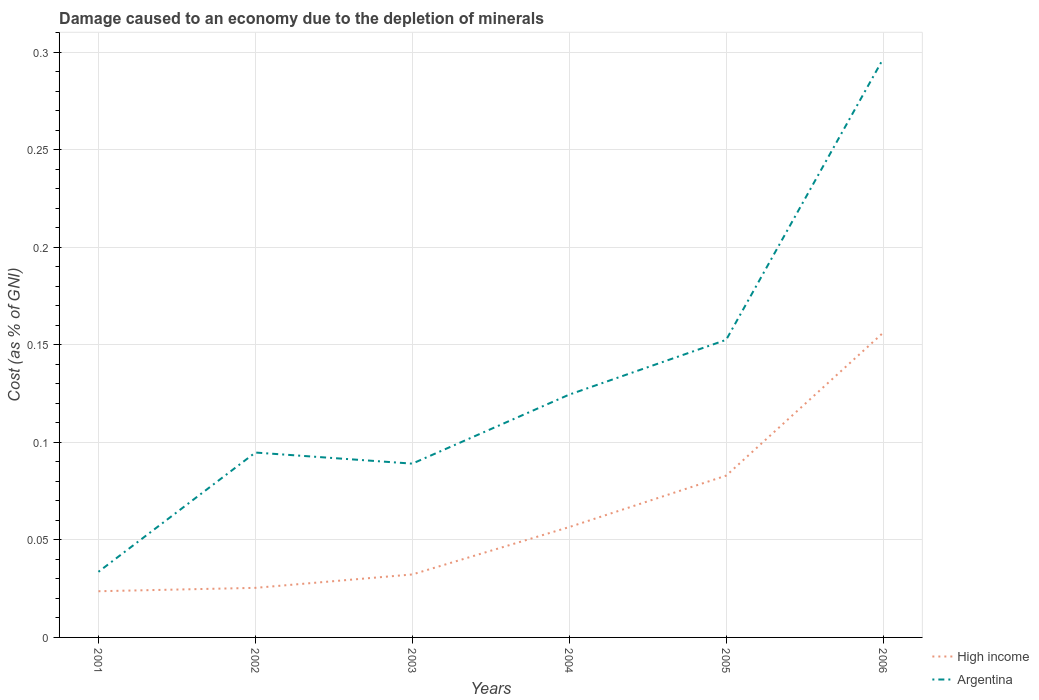How many different coloured lines are there?
Your answer should be very brief. 2. Across all years, what is the maximum cost of damage caused due to the depletion of minerals in Argentina?
Make the answer very short. 0.03. What is the total cost of damage caused due to the depletion of minerals in Argentina in the graph?
Your answer should be compact. -0.17. What is the difference between the highest and the second highest cost of damage caused due to the depletion of minerals in High income?
Your answer should be very brief. 0.13. What is the difference between the highest and the lowest cost of damage caused due to the depletion of minerals in Argentina?
Give a very brief answer. 2. Is the cost of damage caused due to the depletion of minerals in Argentina strictly greater than the cost of damage caused due to the depletion of minerals in High income over the years?
Make the answer very short. No. How many lines are there?
Keep it short and to the point. 2. What is the difference between two consecutive major ticks on the Y-axis?
Offer a terse response. 0.05. Does the graph contain grids?
Ensure brevity in your answer.  Yes. What is the title of the graph?
Your answer should be very brief. Damage caused to an economy due to the depletion of minerals. Does "Luxembourg" appear as one of the legend labels in the graph?
Offer a very short reply. No. What is the label or title of the Y-axis?
Your response must be concise. Cost (as % of GNI). What is the Cost (as % of GNI) of High income in 2001?
Make the answer very short. 0.02. What is the Cost (as % of GNI) in Argentina in 2001?
Offer a very short reply. 0.03. What is the Cost (as % of GNI) in High income in 2002?
Provide a short and direct response. 0.03. What is the Cost (as % of GNI) in Argentina in 2002?
Provide a short and direct response. 0.09. What is the Cost (as % of GNI) of High income in 2003?
Provide a succinct answer. 0.03. What is the Cost (as % of GNI) of Argentina in 2003?
Give a very brief answer. 0.09. What is the Cost (as % of GNI) of High income in 2004?
Your response must be concise. 0.06. What is the Cost (as % of GNI) in Argentina in 2004?
Keep it short and to the point. 0.12. What is the Cost (as % of GNI) in High income in 2005?
Give a very brief answer. 0.08. What is the Cost (as % of GNI) in Argentina in 2005?
Keep it short and to the point. 0.15. What is the Cost (as % of GNI) in High income in 2006?
Your response must be concise. 0.16. What is the Cost (as % of GNI) of Argentina in 2006?
Ensure brevity in your answer.  0.3. Across all years, what is the maximum Cost (as % of GNI) in High income?
Provide a succinct answer. 0.16. Across all years, what is the maximum Cost (as % of GNI) in Argentina?
Give a very brief answer. 0.3. Across all years, what is the minimum Cost (as % of GNI) of High income?
Make the answer very short. 0.02. Across all years, what is the minimum Cost (as % of GNI) in Argentina?
Your response must be concise. 0.03. What is the total Cost (as % of GNI) in High income in the graph?
Provide a succinct answer. 0.38. What is the total Cost (as % of GNI) of Argentina in the graph?
Your response must be concise. 0.79. What is the difference between the Cost (as % of GNI) of High income in 2001 and that in 2002?
Your answer should be very brief. -0. What is the difference between the Cost (as % of GNI) in Argentina in 2001 and that in 2002?
Your answer should be very brief. -0.06. What is the difference between the Cost (as % of GNI) of High income in 2001 and that in 2003?
Keep it short and to the point. -0.01. What is the difference between the Cost (as % of GNI) in Argentina in 2001 and that in 2003?
Your answer should be compact. -0.06. What is the difference between the Cost (as % of GNI) of High income in 2001 and that in 2004?
Offer a terse response. -0.03. What is the difference between the Cost (as % of GNI) in Argentina in 2001 and that in 2004?
Your answer should be very brief. -0.09. What is the difference between the Cost (as % of GNI) in High income in 2001 and that in 2005?
Offer a very short reply. -0.06. What is the difference between the Cost (as % of GNI) of Argentina in 2001 and that in 2005?
Keep it short and to the point. -0.12. What is the difference between the Cost (as % of GNI) in High income in 2001 and that in 2006?
Your answer should be very brief. -0.13. What is the difference between the Cost (as % of GNI) of Argentina in 2001 and that in 2006?
Provide a short and direct response. -0.26. What is the difference between the Cost (as % of GNI) in High income in 2002 and that in 2003?
Give a very brief answer. -0.01. What is the difference between the Cost (as % of GNI) of Argentina in 2002 and that in 2003?
Offer a terse response. 0.01. What is the difference between the Cost (as % of GNI) of High income in 2002 and that in 2004?
Offer a terse response. -0.03. What is the difference between the Cost (as % of GNI) of Argentina in 2002 and that in 2004?
Offer a very short reply. -0.03. What is the difference between the Cost (as % of GNI) in High income in 2002 and that in 2005?
Offer a terse response. -0.06. What is the difference between the Cost (as % of GNI) of Argentina in 2002 and that in 2005?
Offer a terse response. -0.06. What is the difference between the Cost (as % of GNI) in High income in 2002 and that in 2006?
Offer a terse response. -0.13. What is the difference between the Cost (as % of GNI) of Argentina in 2002 and that in 2006?
Provide a short and direct response. -0.2. What is the difference between the Cost (as % of GNI) in High income in 2003 and that in 2004?
Give a very brief answer. -0.02. What is the difference between the Cost (as % of GNI) in Argentina in 2003 and that in 2004?
Offer a very short reply. -0.04. What is the difference between the Cost (as % of GNI) in High income in 2003 and that in 2005?
Make the answer very short. -0.05. What is the difference between the Cost (as % of GNI) in Argentina in 2003 and that in 2005?
Keep it short and to the point. -0.06. What is the difference between the Cost (as % of GNI) in High income in 2003 and that in 2006?
Give a very brief answer. -0.12. What is the difference between the Cost (as % of GNI) of Argentina in 2003 and that in 2006?
Your answer should be very brief. -0.21. What is the difference between the Cost (as % of GNI) in High income in 2004 and that in 2005?
Make the answer very short. -0.03. What is the difference between the Cost (as % of GNI) of Argentina in 2004 and that in 2005?
Ensure brevity in your answer.  -0.03. What is the difference between the Cost (as % of GNI) in High income in 2004 and that in 2006?
Your response must be concise. -0.1. What is the difference between the Cost (as % of GNI) in Argentina in 2004 and that in 2006?
Your response must be concise. -0.17. What is the difference between the Cost (as % of GNI) of High income in 2005 and that in 2006?
Provide a short and direct response. -0.07. What is the difference between the Cost (as % of GNI) of Argentina in 2005 and that in 2006?
Ensure brevity in your answer.  -0.14. What is the difference between the Cost (as % of GNI) in High income in 2001 and the Cost (as % of GNI) in Argentina in 2002?
Keep it short and to the point. -0.07. What is the difference between the Cost (as % of GNI) in High income in 2001 and the Cost (as % of GNI) in Argentina in 2003?
Your response must be concise. -0.07. What is the difference between the Cost (as % of GNI) of High income in 2001 and the Cost (as % of GNI) of Argentina in 2004?
Your response must be concise. -0.1. What is the difference between the Cost (as % of GNI) in High income in 2001 and the Cost (as % of GNI) in Argentina in 2005?
Your answer should be very brief. -0.13. What is the difference between the Cost (as % of GNI) of High income in 2001 and the Cost (as % of GNI) of Argentina in 2006?
Offer a very short reply. -0.27. What is the difference between the Cost (as % of GNI) in High income in 2002 and the Cost (as % of GNI) in Argentina in 2003?
Offer a very short reply. -0.06. What is the difference between the Cost (as % of GNI) of High income in 2002 and the Cost (as % of GNI) of Argentina in 2004?
Provide a short and direct response. -0.1. What is the difference between the Cost (as % of GNI) of High income in 2002 and the Cost (as % of GNI) of Argentina in 2005?
Offer a very short reply. -0.13. What is the difference between the Cost (as % of GNI) of High income in 2002 and the Cost (as % of GNI) of Argentina in 2006?
Your response must be concise. -0.27. What is the difference between the Cost (as % of GNI) in High income in 2003 and the Cost (as % of GNI) in Argentina in 2004?
Provide a short and direct response. -0.09. What is the difference between the Cost (as % of GNI) of High income in 2003 and the Cost (as % of GNI) of Argentina in 2005?
Your answer should be compact. -0.12. What is the difference between the Cost (as % of GNI) of High income in 2003 and the Cost (as % of GNI) of Argentina in 2006?
Your answer should be very brief. -0.26. What is the difference between the Cost (as % of GNI) of High income in 2004 and the Cost (as % of GNI) of Argentina in 2005?
Provide a short and direct response. -0.1. What is the difference between the Cost (as % of GNI) of High income in 2004 and the Cost (as % of GNI) of Argentina in 2006?
Keep it short and to the point. -0.24. What is the difference between the Cost (as % of GNI) in High income in 2005 and the Cost (as % of GNI) in Argentina in 2006?
Offer a terse response. -0.21. What is the average Cost (as % of GNI) of High income per year?
Provide a succinct answer. 0.06. What is the average Cost (as % of GNI) of Argentina per year?
Offer a very short reply. 0.13. In the year 2001, what is the difference between the Cost (as % of GNI) of High income and Cost (as % of GNI) of Argentina?
Ensure brevity in your answer.  -0.01. In the year 2002, what is the difference between the Cost (as % of GNI) of High income and Cost (as % of GNI) of Argentina?
Give a very brief answer. -0.07. In the year 2003, what is the difference between the Cost (as % of GNI) in High income and Cost (as % of GNI) in Argentina?
Ensure brevity in your answer.  -0.06. In the year 2004, what is the difference between the Cost (as % of GNI) of High income and Cost (as % of GNI) of Argentina?
Your response must be concise. -0.07. In the year 2005, what is the difference between the Cost (as % of GNI) of High income and Cost (as % of GNI) of Argentina?
Your response must be concise. -0.07. In the year 2006, what is the difference between the Cost (as % of GNI) in High income and Cost (as % of GNI) in Argentina?
Make the answer very short. -0.14. What is the ratio of the Cost (as % of GNI) in High income in 2001 to that in 2002?
Offer a terse response. 0.93. What is the ratio of the Cost (as % of GNI) of Argentina in 2001 to that in 2002?
Make the answer very short. 0.35. What is the ratio of the Cost (as % of GNI) in High income in 2001 to that in 2003?
Make the answer very short. 0.73. What is the ratio of the Cost (as % of GNI) of Argentina in 2001 to that in 2003?
Your answer should be very brief. 0.38. What is the ratio of the Cost (as % of GNI) of High income in 2001 to that in 2004?
Your answer should be compact. 0.42. What is the ratio of the Cost (as % of GNI) of Argentina in 2001 to that in 2004?
Offer a very short reply. 0.27. What is the ratio of the Cost (as % of GNI) of High income in 2001 to that in 2005?
Your answer should be compact. 0.29. What is the ratio of the Cost (as % of GNI) of Argentina in 2001 to that in 2005?
Your answer should be very brief. 0.22. What is the ratio of the Cost (as % of GNI) in High income in 2001 to that in 2006?
Ensure brevity in your answer.  0.15. What is the ratio of the Cost (as % of GNI) of Argentina in 2001 to that in 2006?
Give a very brief answer. 0.11. What is the ratio of the Cost (as % of GNI) of High income in 2002 to that in 2003?
Make the answer very short. 0.79. What is the ratio of the Cost (as % of GNI) in Argentina in 2002 to that in 2003?
Keep it short and to the point. 1.06. What is the ratio of the Cost (as % of GNI) of High income in 2002 to that in 2004?
Your answer should be very brief. 0.45. What is the ratio of the Cost (as % of GNI) of Argentina in 2002 to that in 2004?
Give a very brief answer. 0.76. What is the ratio of the Cost (as % of GNI) of High income in 2002 to that in 2005?
Make the answer very short. 0.31. What is the ratio of the Cost (as % of GNI) of Argentina in 2002 to that in 2005?
Offer a terse response. 0.62. What is the ratio of the Cost (as % of GNI) of High income in 2002 to that in 2006?
Your answer should be very brief. 0.16. What is the ratio of the Cost (as % of GNI) of Argentina in 2002 to that in 2006?
Provide a short and direct response. 0.32. What is the ratio of the Cost (as % of GNI) in High income in 2003 to that in 2004?
Keep it short and to the point. 0.57. What is the ratio of the Cost (as % of GNI) of Argentina in 2003 to that in 2004?
Your answer should be compact. 0.72. What is the ratio of the Cost (as % of GNI) of High income in 2003 to that in 2005?
Your answer should be very brief. 0.39. What is the ratio of the Cost (as % of GNI) of Argentina in 2003 to that in 2005?
Provide a short and direct response. 0.58. What is the ratio of the Cost (as % of GNI) of High income in 2003 to that in 2006?
Ensure brevity in your answer.  0.21. What is the ratio of the Cost (as % of GNI) of Argentina in 2003 to that in 2006?
Offer a very short reply. 0.3. What is the ratio of the Cost (as % of GNI) in High income in 2004 to that in 2005?
Your answer should be compact. 0.68. What is the ratio of the Cost (as % of GNI) of Argentina in 2004 to that in 2005?
Your response must be concise. 0.82. What is the ratio of the Cost (as % of GNI) of High income in 2004 to that in 2006?
Give a very brief answer. 0.36. What is the ratio of the Cost (as % of GNI) in Argentina in 2004 to that in 2006?
Your answer should be compact. 0.42. What is the ratio of the Cost (as % of GNI) of High income in 2005 to that in 2006?
Ensure brevity in your answer.  0.53. What is the ratio of the Cost (as % of GNI) in Argentina in 2005 to that in 2006?
Make the answer very short. 0.51. What is the difference between the highest and the second highest Cost (as % of GNI) of High income?
Your answer should be very brief. 0.07. What is the difference between the highest and the second highest Cost (as % of GNI) in Argentina?
Give a very brief answer. 0.14. What is the difference between the highest and the lowest Cost (as % of GNI) in High income?
Provide a succinct answer. 0.13. What is the difference between the highest and the lowest Cost (as % of GNI) in Argentina?
Your answer should be compact. 0.26. 